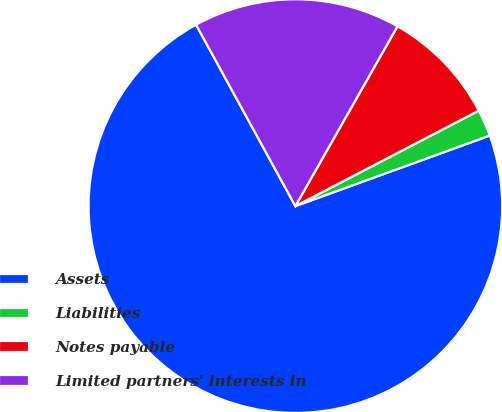Convert chart to OTSL. <chart><loc_0><loc_0><loc_500><loc_500><pie_chart><fcel>Assets<fcel>Liabilities<fcel>Notes payable<fcel>Limited partners' interests in<nl><fcel>72.57%<fcel>2.1%<fcel>9.14%<fcel>16.19%<nl></chart> 